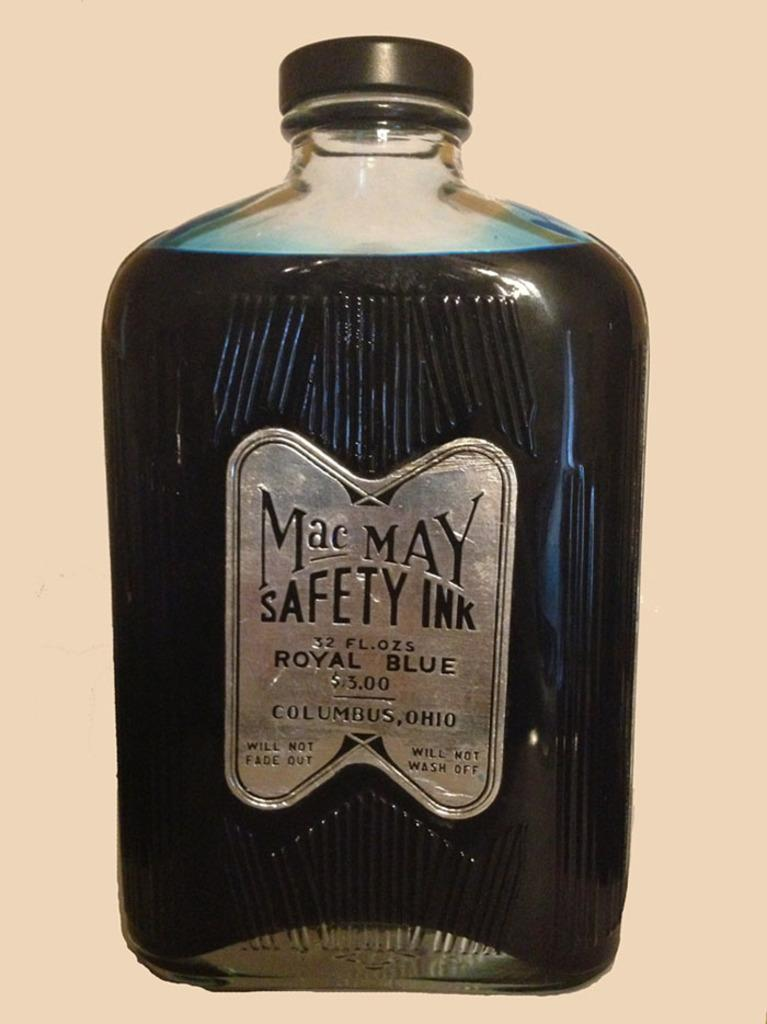<image>
Provide a brief description of the given image. a close up of Mac May Safety Ink in royal blue 